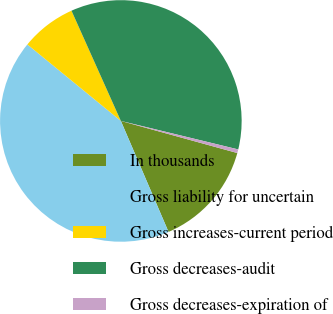<chart> <loc_0><loc_0><loc_500><loc_500><pie_chart><fcel>In thousands<fcel>Gross liability for uncertain<fcel>Gross increases-current period<fcel>Gross decreases-audit<fcel>Gross decreases-expiration of<nl><fcel>14.26%<fcel>42.37%<fcel>7.38%<fcel>35.49%<fcel>0.49%<nl></chart> 